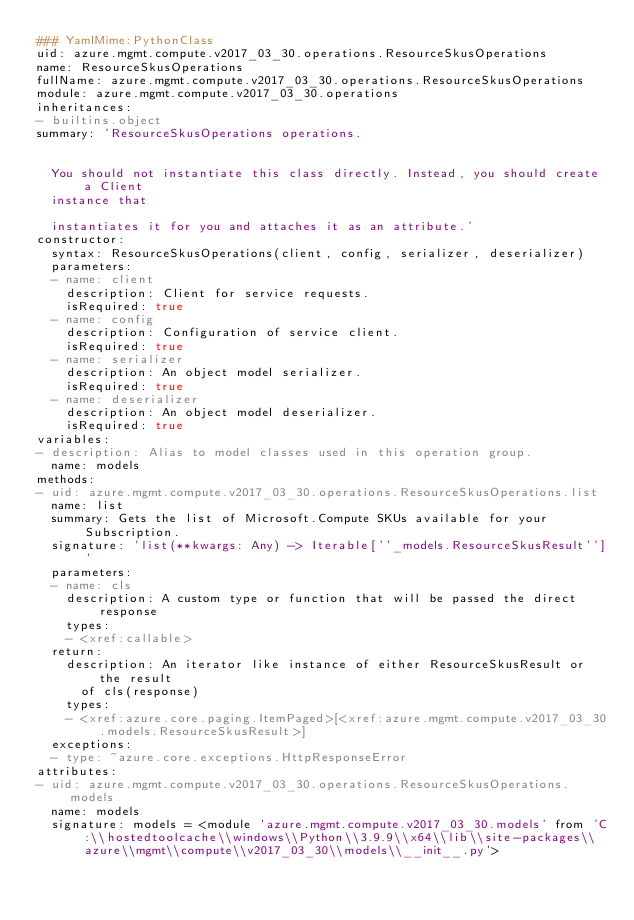<code> <loc_0><loc_0><loc_500><loc_500><_YAML_>### YamlMime:PythonClass
uid: azure.mgmt.compute.v2017_03_30.operations.ResourceSkusOperations
name: ResourceSkusOperations
fullName: azure.mgmt.compute.v2017_03_30.operations.ResourceSkusOperations
module: azure.mgmt.compute.v2017_03_30.operations
inheritances:
- builtins.object
summary: 'ResourceSkusOperations operations.


  You should not instantiate this class directly. Instead, you should create a Client
  instance that

  instantiates it for you and attaches it as an attribute.'
constructor:
  syntax: ResourceSkusOperations(client, config, serializer, deserializer)
  parameters:
  - name: client
    description: Client for service requests.
    isRequired: true
  - name: config
    description: Configuration of service client.
    isRequired: true
  - name: serializer
    description: An object model serializer.
    isRequired: true
  - name: deserializer
    description: An object model deserializer.
    isRequired: true
variables:
- description: Alias to model classes used in this operation group.
  name: models
methods:
- uid: azure.mgmt.compute.v2017_03_30.operations.ResourceSkusOperations.list
  name: list
  summary: Gets the list of Microsoft.Compute SKUs available for your Subscription.
  signature: 'list(**kwargs: Any) -> Iterable[''_models.ResourceSkusResult'']'
  parameters:
  - name: cls
    description: A custom type or function that will be passed the direct response
    types:
    - <xref:callable>
  return:
    description: An iterator like instance of either ResourceSkusResult or the result
      of cls(response)
    types:
    - <xref:azure.core.paging.ItemPaged>[<xref:azure.mgmt.compute.v2017_03_30.models.ResourceSkusResult>]
  exceptions:
  - type: ~azure.core.exceptions.HttpResponseError
attributes:
- uid: azure.mgmt.compute.v2017_03_30.operations.ResourceSkusOperations.models
  name: models
  signature: models = <module 'azure.mgmt.compute.v2017_03_30.models' from 'C:\\hostedtoolcache\\windows\\Python\\3.9.9\\x64\\lib\\site-packages\\azure\\mgmt\\compute\\v2017_03_30\\models\\__init__.py'>
</code> 